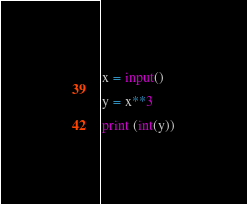Convert code to text. <code><loc_0><loc_0><loc_500><loc_500><_Python_>x = input()

y = x**3

print (int(y))</code> 